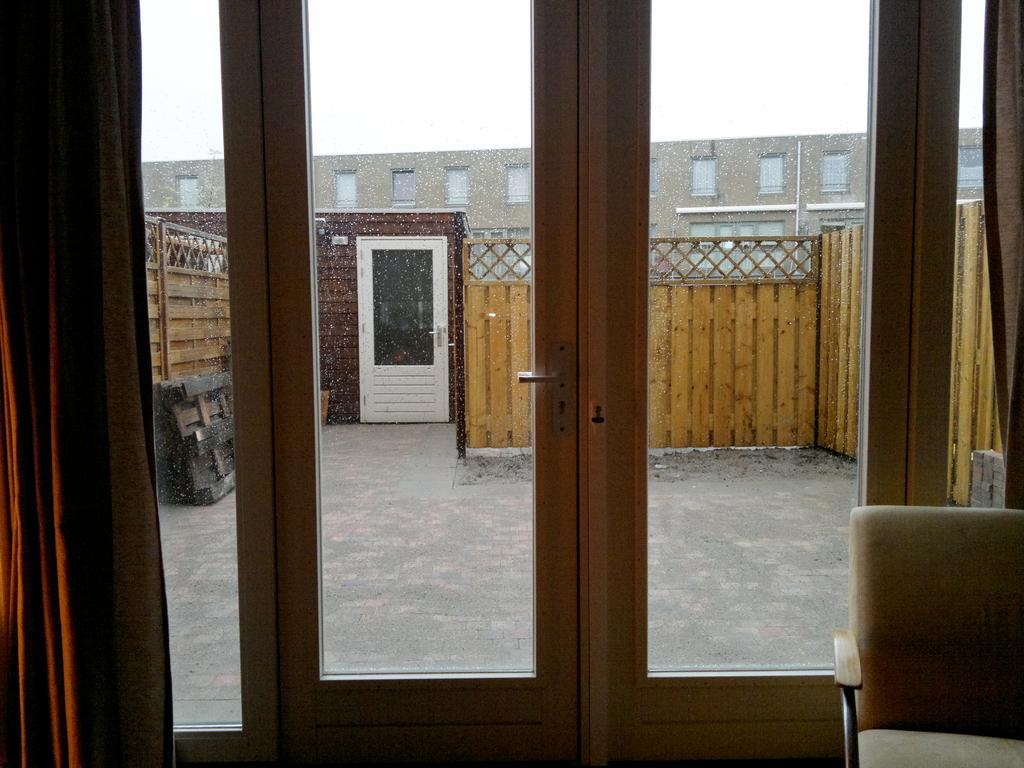Can you describe this image briefly? In this picture I can see doors, chair, wooden fence. I can see a building, and in the background there is the sky. 